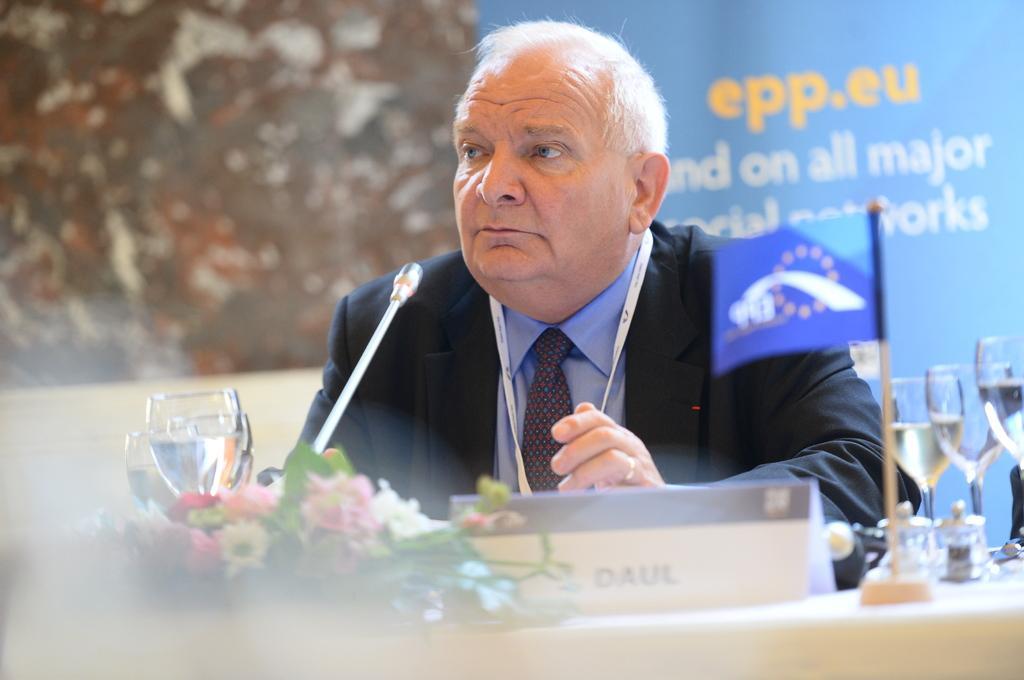Please provide a concise description of this image. In this image we can see a person wearing a tag. In front of him there is a mic, glasses, flower bouquet, flag, name board and few other items. In the background there is a banner with something written. 